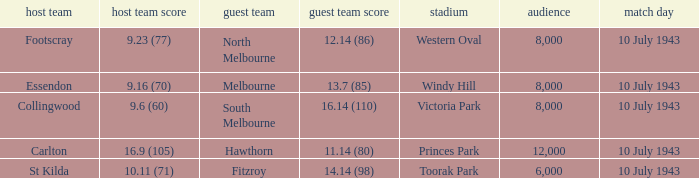When the Home team of carlton played, what was their score? 16.9 (105). 